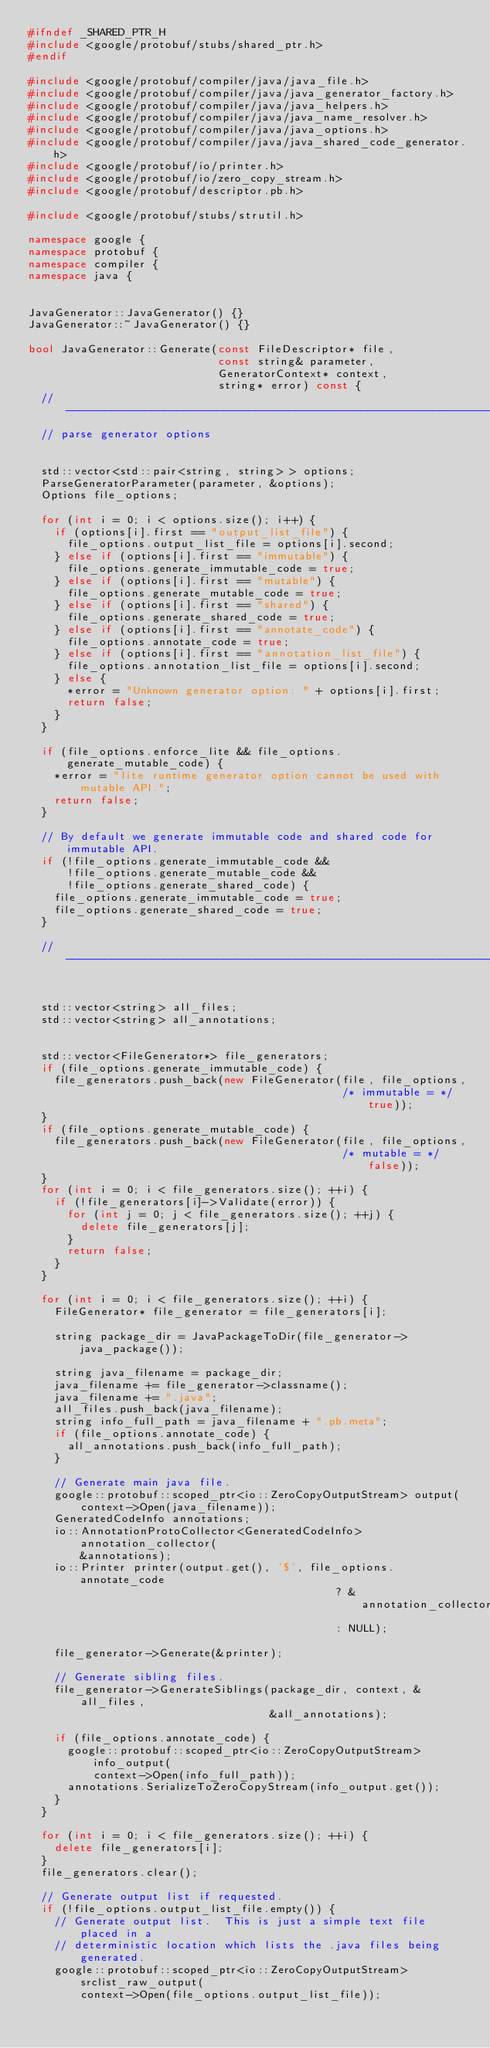Convert code to text. <code><loc_0><loc_0><loc_500><loc_500><_C++_>#ifndef _SHARED_PTR_H
#include <google/protobuf/stubs/shared_ptr.h>
#endif

#include <google/protobuf/compiler/java/java_file.h>
#include <google/protobuf/compiler/java/java_generator_factory.h>
#include <google/protobuf/compiler/java/java_helpers.h>
#include <google/protobuf/compiler/java/java_name_resolver.h>
#include <google/protobuf/compiler/java/java_options.h>
#include <google/protobuf/compiler/java/java_shared_code_generator.h>
#include <google/protobuf/io/printer.h>
#include <google/protobuf/io/zero_copy_stream.h>
#include <google/protobuf/descriptor.pb.h>

#include <google/protobuf/stubs/strutil.h>

namespace google {
namespace protobuf {
namespace compiler {
namespace java {


JavaGenerator::JavaGenerator() {}
JavaGenerator::~JavaGenerator() {}

bool JavaGenerator::Generate(const FileDescriptor* file,
                             const string& parameter,
                             GeneratorContext* context,
                             string* error) const {
  // -----------------------------------------------------------------
  // parse generator options


  std::vector<std::pair<string, string> > options;
  ParseGeneratorParameter(parameter, &options);
  Options file_options;

  for (int i = 0; i < options.size(); i++) {
    if (options[i].first == "output_list_file") {
      file_options.output_list_file = options[i].second;
    } else if (options[i].first == "immutable") {
      file_options.generate_immutable_code = true;
    } else if (options[i].first == "mutable") {
      file_options.generate_mutable_code = true;
    } else if (options[i].first == "shared") {
      file_options.generate_shared_code = true;
    } else if (options[i].first == "annotate_code") {
      file_options.annotate_code = true;
    } else if (options[i].first == "annotation_list_file") {
      file_options.annotation_list_file = options[i].second;
    } else {
      *error = "Unknown generator option: " + options[i].first;
      return false;
    }
  }

  if (file_options.enforce_lite && file_options.generate_mutable_code) {
    *error = "lite runtime generator option cannot be used with mutable API.";
    return false;
  }

  // By default we generate immutable code and shared code for immutable API.
  if (!file_options.generate_immutable_code &&
      !file_options.generate_mutable_code &&
      !file_options.generate_shared_code) {
    file_options.generate_immutable_code = true;
    file_options.generate_shared_code = true;
  }

  // -----------------------------------------------------------------


  std::vector<string> all_files;
  std::vector<string> all_annotations;


  std::vector<FileGenerator*> file_generators;
  if (file_options.generate_immutable_code) {
    file_generators.push_back(new FileGenerator(file, file_options,
                                                /* immutable = */ true));
  }
  if (file_options.generate_mutable_code) {
    file_generators.push_back(new FileGenerator(file, file_options,
                                                /* mutable = */ false));
  }
  for (int i = 0; i < file_generators.size(); ++i) {
    if (!file_generators[i]->Validate(error)) {
      for (int j = 0; j < file_generators.size(); ++j) {
        delete file_generators[j];
      }
      return false;
    }
  }

  for (int i = 0; i < file_generators.size(); ++i) {
    FileGenerator* file_generator = file_generators[i];

    string package_dir = JavaPackageToDir(file_generator->java_package());

    string java_filename = package_dir;
    java_filename += file_generator->classname();
    java_filename += ".java";
    all_files.push_back(java_filename);
    string info_full_path = java_filename + ".pb.meta";
    if (file_options.annotate_code) {
      all_annotations.push_back(info_full_path);
    }

    // Generate main java file.
    google::protobuf::scoped_ptr<io::ZeroCopyOutputStream> output(
        context->Open(java_filename));
    GeneratedCodeInfo annotations;
    io::AnnotationProtoCollector<GeneratedCodeInfo> annotation_collector(
        &annotations);
    io::Printer printer(output.get(), '$', file_options.annotate_code
                                               ? &annotation_collector
                                               : NULL);

    file_generator->Generate(&printer);

    // Generate sibling files.
    file_generator->GenerateSiblings(package_dir, context, &all_files,
                                     &all_annotations);

    if (file_options.annotate_code) {
      google::protobuf::scoped_ptr<io::ZeroCopyOutputStream> info_output(
          context->Open(info_full_path));
      annotations.SerializeToZeroCopyStream(info_output.get());
    }
  }

  for (int i = 0; i < file_generators.size(); ++i) {
    delete file_generators[i];
  }
  file_generators.clear();

  // Generate output list if requested.
  if (!file_options.output_list_file.empty()) {
    // Generate output list.  This is just a simple text file placed in a
    // deterministic location which lists the .java files being generated.
    google::protobuf::scoped_ptr<io::ZeroCopyOutputStream> srclist_raw_output(
        context->Open(file_options.output_list_file));</code> 